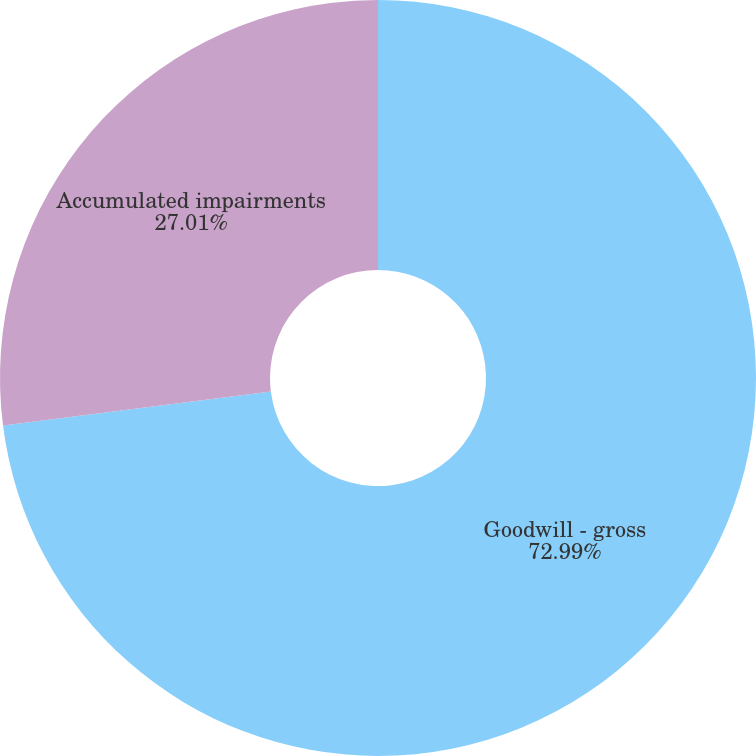<chart> <loc_0><loc_0><loc_500><loc_500><pie_chart><fcel>Goodwill - gross<fcel>Accumulated impairments<nl><fcel>72.99%<fcel>27.01%<nl></chart> 